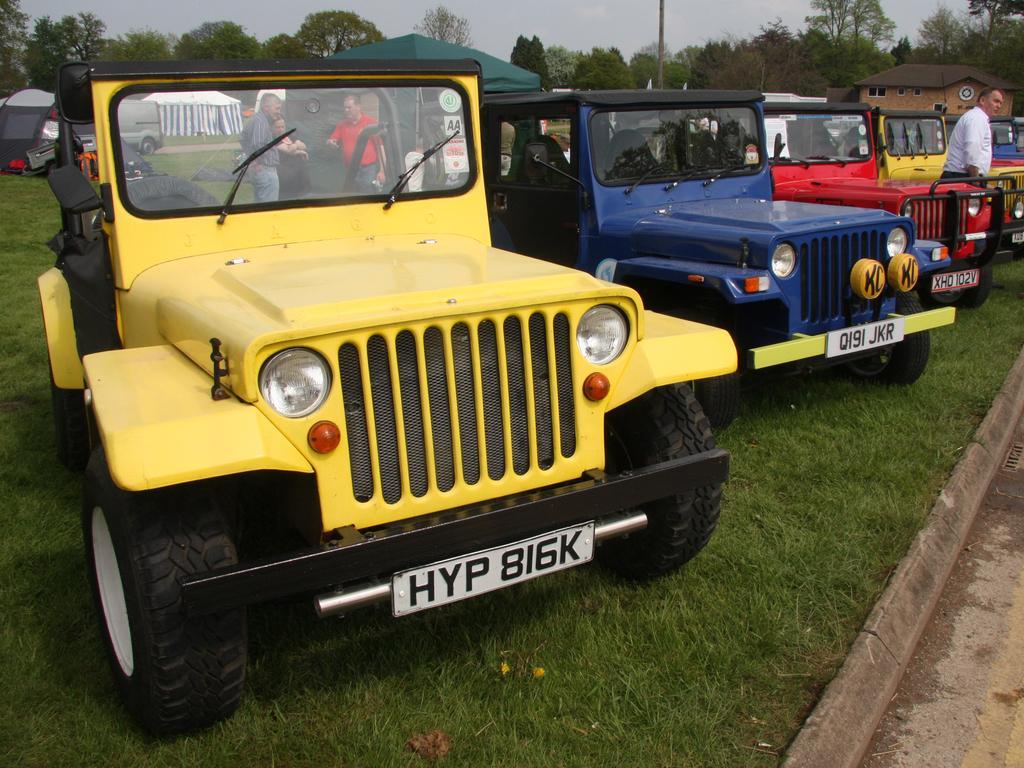In one or two sentences, can you explain what this image depicts? In this image there are few jeeps parked on the surface of the grass, behind them there are a few people standing, behind them there are few tents, behind the tents there are trees. 